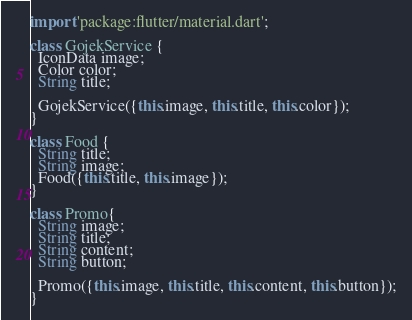<code> <loc_0><loc_0><loc_500><loc_500><_Dart_>import 'package:flutter/material.dart';

class GojekService {
  IconData image;
  Color color;
  String title;

  GojekService({this.image, this.title, this.color});
}

class Food {
  String title;
  String image;
  Food({this.title, this.image});
}

class Promo{
  String image;
  String title;
  String content;
  String button;

  Promo({this.image, this.title, this.content, this.button});
}
</code> 